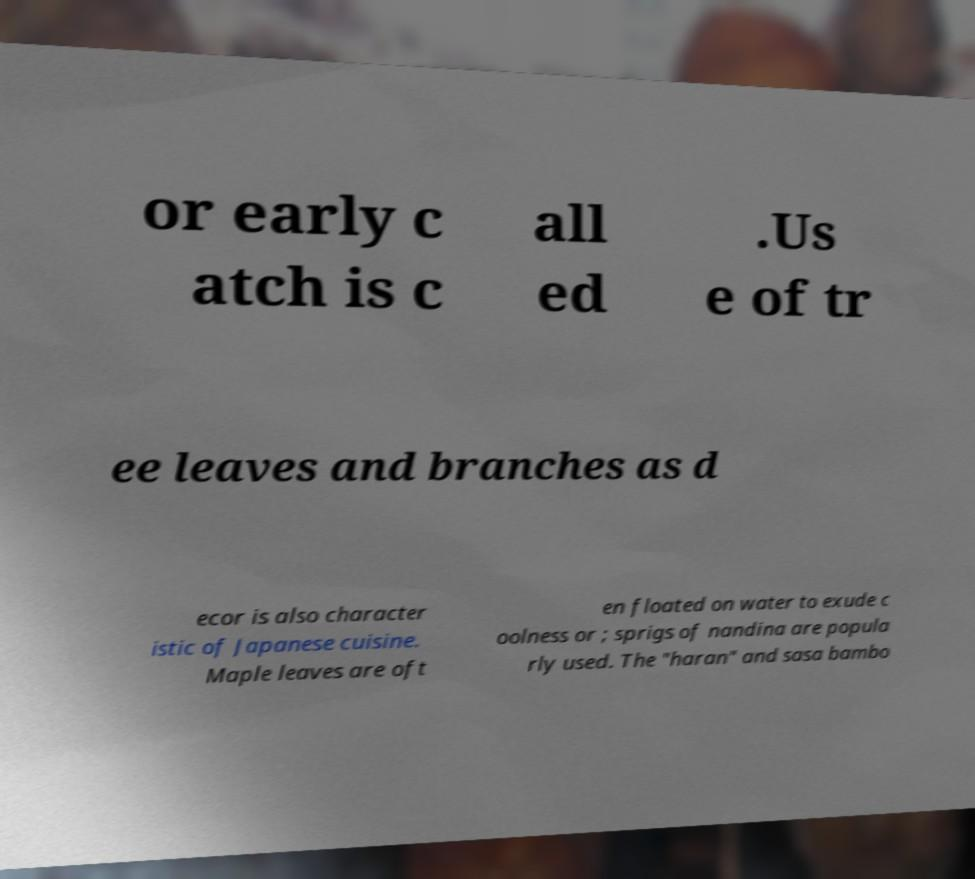Please read and relay the text visible in this image. What does it say? or early c atch is c all ed .Us e of tr ee leaves and branches as d ecor is also character istic of Japanese cuisine. Maple leaves are oft en floated on water to exude c oolness or ; sprigs of nandina are popula rly used. The "haran" and sasa bambo 